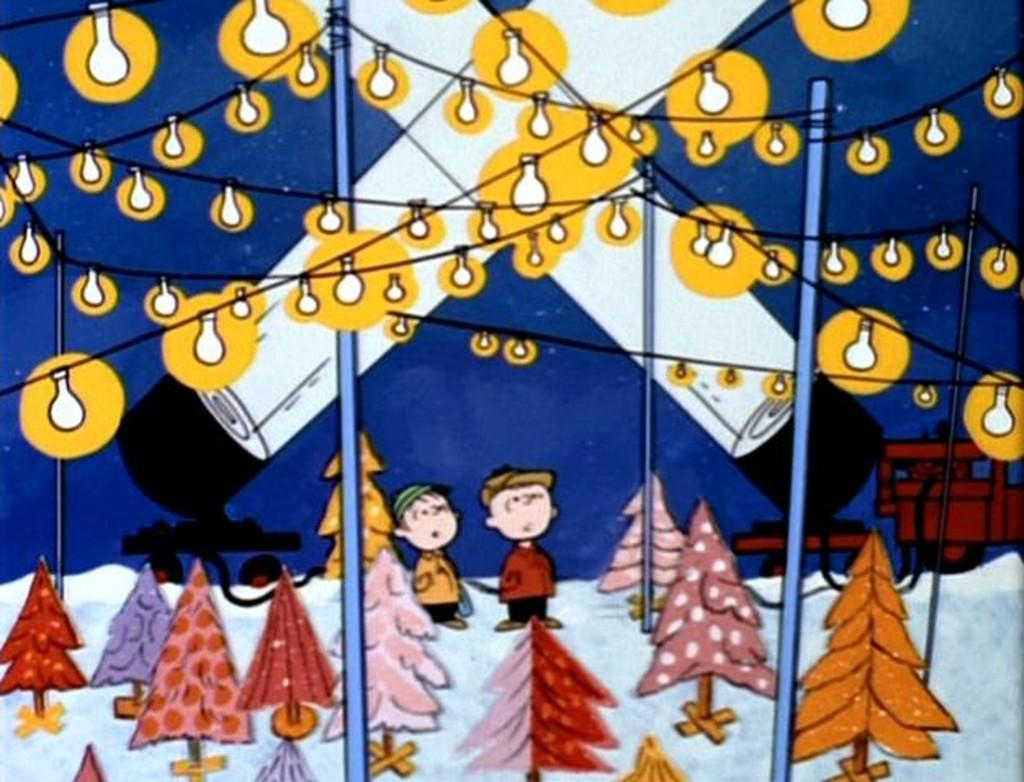What type of picture is in the image? The image contains a cartoon picture. What type of light sources are present in the image? There are electrical lights and flashlights in the image. What type of decorations are present in the image? There are Christmas trees in the image. Who or what is present in the image? There are persons and a motor vehicle in the image. What part of the natural environment is visible in the image? The sky is visible in the image. What type of instrument is being played by the person in the image? There is no person playing an instrument in the image. What type of relation exists between the persons in the image? There is no information about the relationship between the persons in the image. What type of loss is being experienced by the person in the image? There is no indication of any loss being experienced by a person in the image. 